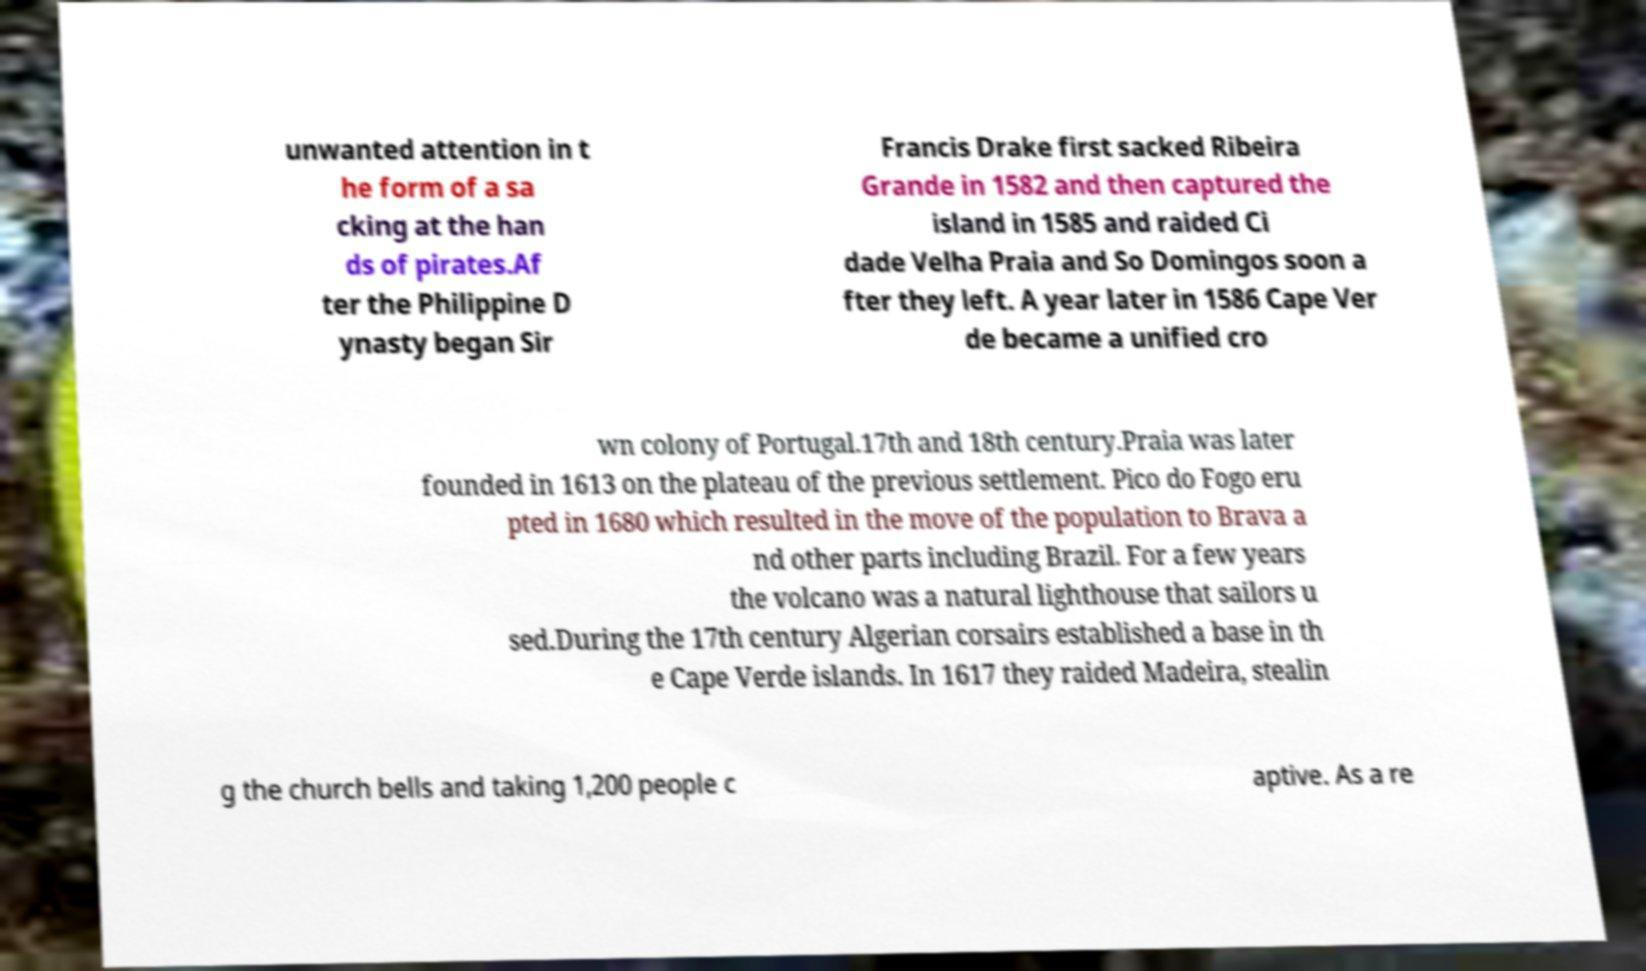Can you read and provide the text displayed in the image?This photo seems to have some interesting text. Can you extract and type it out for me? unwanted attention in t he form of a sa cking at the han ds of pirates.Af ter the Philippine D ynasty began Sir Francis Drake first sacked Ribeira Grande in 1582 and then captured the island in 1585 and raided Ci dade Velha Praia and So Domingos soon a fter they left. A year later in 1586 Cape Ver de became a unified cro wn colony of Portugal.17th and 18th century.Praia was later founded in 1613 on the plateau of the previous settlement. Pico do Fogo eru pted in 1680 which resulted in the move of the population to Brava a nd other parts including Brazil. For a few years the volcano was a natural lighthouse that sailors u sed.During the 17th century Algerian corsairs established a base in th e Cape Verde islands. In 1617 they raided Madeira, stealin g the church bells and taking 1,200 people c aptive. As a re 